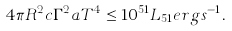Convert formula to latex. <formula><loc_0><loc_0><loc_500><loc_500>4 \pi R ^ { 2 } c \Gamma ^ { 2 } a T ^ { 4 } \leq 1 0 ^ { 5 1 } L _ { 5 1 } e r g s ^ { - 1 } .</formula> 